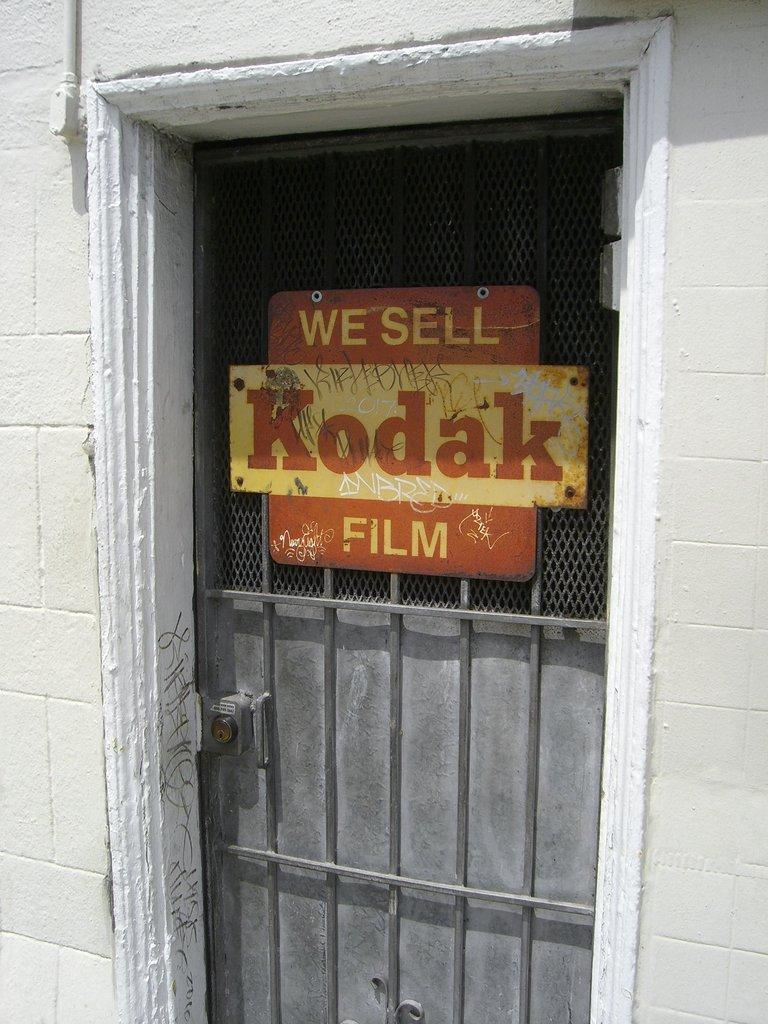What is the main object in the picture? There is a door in the picture. Can you describe anything else in front of the door? There is some text visible in front of the door. How many snakes are slithering on the land in the image? There are no snakes visible in the image; it only features a door and some text. 